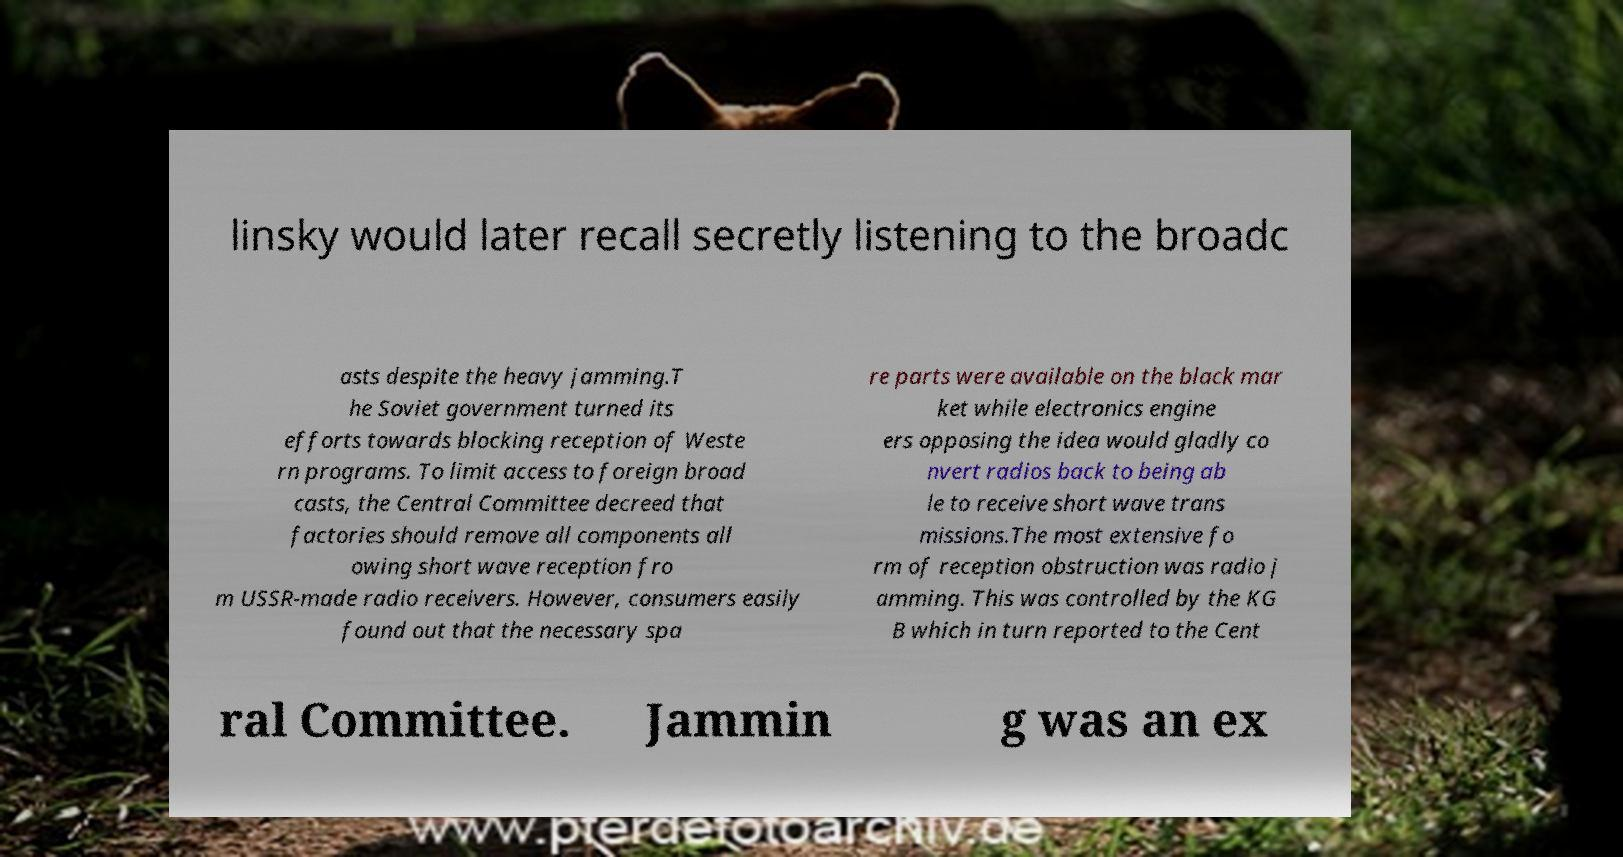There's text embedded in this image that I need extracted. Can you transcribe it verbatim? linsky would later recall secretly listening to the broadc asts despite the heavy jamming.T he Soviet government turned its efforts towards blocking reception of Weste rn programs. To limit access to foreign broad casts, the Central Committee decreed that factories should remove all components all owing short wave reception fro m USSR-made radio receivers. However, consumers easily found out that the necessary spa re parts were available on the black mar ket while electronics engine ers opposing the idea would gladly co nvert radios back to being ab le to receive short wave trans missions.The most extensive fo rm of reception obstruction was radio j amming. This was controlled by the KG B which in turn reported to the Cent ral Committee. Jammin g was an ex 